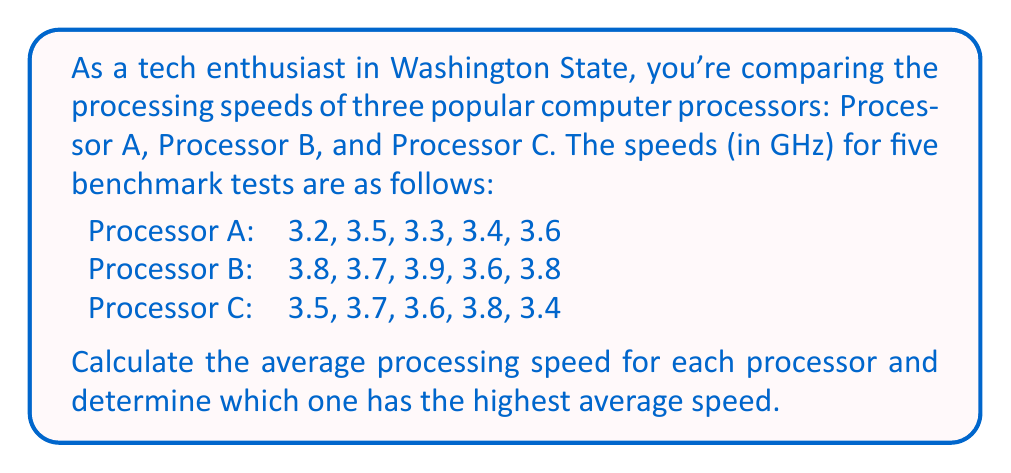Show me your answer to this math problem. To solve this problem, we need to calculate the average (mean) processing speed for each processor and then compare them. Let's go through this step-by-step:

1. Calculate the average for Processor A:
   $$\text{Average}_A = \frac{3.2 + 3.5 + 3.3 + 3.4 + 3.6}{5} = \frac{17}{5} = 3.4 \text{ GHz}$$

2. Calculate the average for Processor B:
   $$\text{Average}_B = \frac{3.8 + 3.7 + 3.9 + 3.6 + 3.8}{5} = \frac{19}{5} = 3.76 \text{ GHz}$$

3. Calculate the average for Processor C:
   $$\text{Average}_C = \frac{3.5 + 3.7 + 3.6 + 3.8 + 3.4}{5} = \frac{18}{5} = 3.6 \text{ GHz}$$

4. Compare the averages:
   Processor A: 3.4 GHz
   Processor B: 3.76 GHz
   Processor C: 3.6 GHz

We can see that Processor B has the highest average processing speed at 3.76 GHz.
Answer: Processor B has the highest average processing speed at 3.76 GHz. 